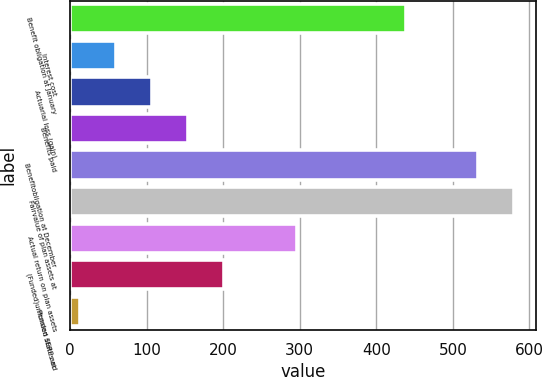Convert chart. <chart><loc_0><loc_0><loc_500><loc_500><bar_chart><fcel>Benefit obligation at January<fcel>Interest cost<fcel>Actuarial loss (gain)<fcel>Benefits paid<fcel>Benefitobligation at December<fcel>Fairvalue of plan assets at<fcel>Actual return on plan assets<fcel>(Funded)unfunded status at<fcel>Pension SERP and<nl><fcel>438.4<fcel>59.72<fcel>106.94<fcel>154.16<fcel>532.84<fcel>580.06<fcel>295.82<fcel>201.38<fcel>12.5<nl></chart> 